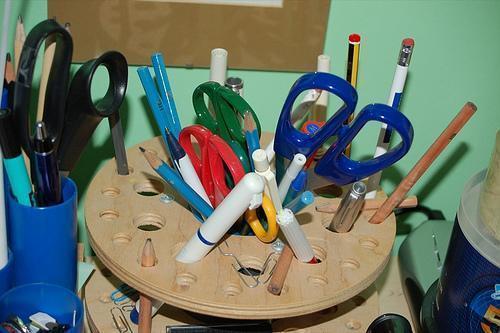What class are these supplies needed for?
Indicate the correct response by choosing from the four available options to answer the question.
Options: English class, gym class, math class, art class. Art class. 